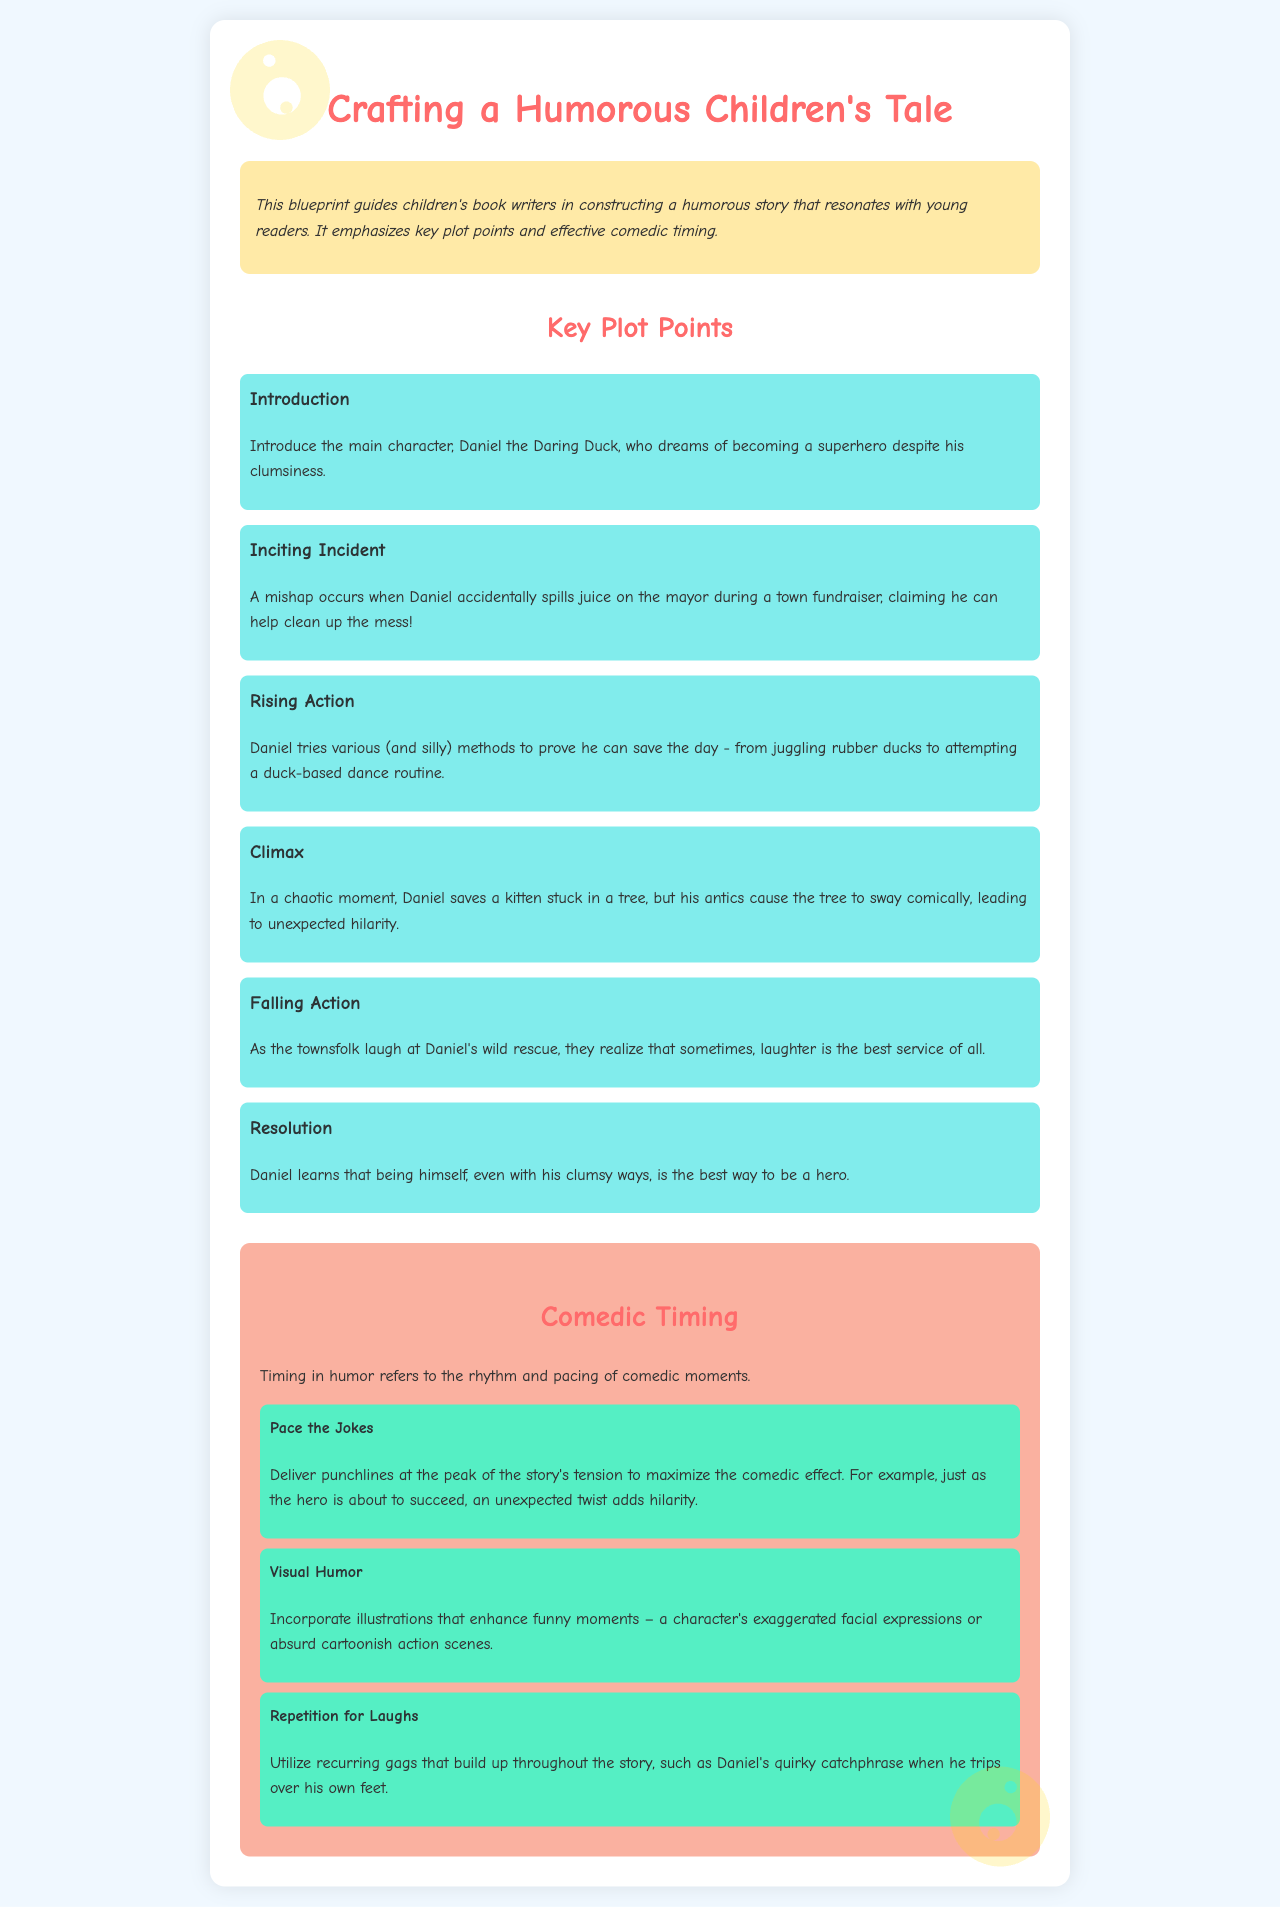What is the main character's name? The main character introduced in the story is Daniel the Daring Duck, as stated in the introduction.
Answer: Daniel the Daring Duck What happens during the inciting incident? It describes a mishap where Daniel spills juice on the mayor, leading to a comical situation.
Answer: Spills juice on the mayor What is one method Daniel tries during the rising action? It mentions various (and silly) methods Daniel tries, including juggling rubber ducks.
Answer: Juggling rubber ducks What is the climax of the story? The climax involves Daniel saving a kitten, causing comedic chaos with a swaying tree.
Answer: Saves a kitten stuck in a tree What is the lesson Daniel learns at the resolution? The resolution outlines that Daniel learns to embrace his clumsy ways as a form of heroism.
Answer: Being himself How should jokes be paced for comedic effect? The document states that punchlines should be delivered at the peak of tension.
Answer: At the peak of the story's tension What does visual humor involve? It indicates that visual humor includes illustrations enhancing funny moments and expressions.
Answer: Illustrations that enhance funny moments What is one tip for using repetition for laughs? The manual suggests utilizing recurring gags, such as Daniel's quirky catchphrase.
Answer: Daniel's quirky catchphrase What color scheme is used for the background? The background color of the document is described as light blue (f0f8ff).
Answer: Light blue 